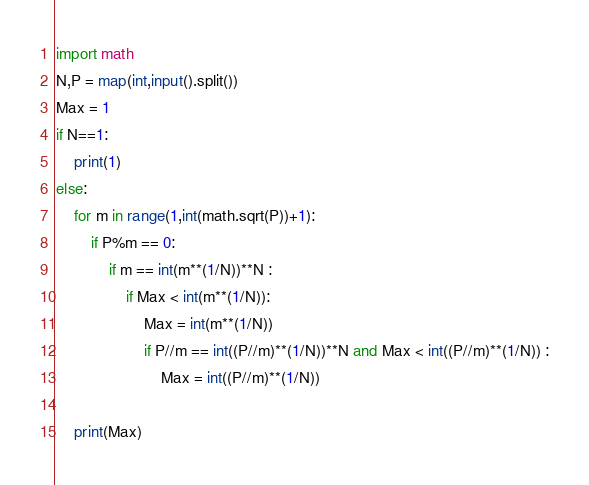Convert code to text. <code><loc_0><loc_0><loc_500><loc_500><_Python_>import math
N,P = map(int,input().split())
Max = 1
if N==1:
    print(1)
else:
    for m in range(1,int(math.sqrt(P))+1):
        if P%m == 0:
            if m == int(m**(1/N))**N :
                if Max < int(m**(1/N)):
                    Max = int(m**(1/N))
                    if P//m == int((P//m)**(1/N))**N and Max < int((P//m)**(1/N)) :
                        Max = int((P//m)**(1/N))
            
    print(Max)</code> 